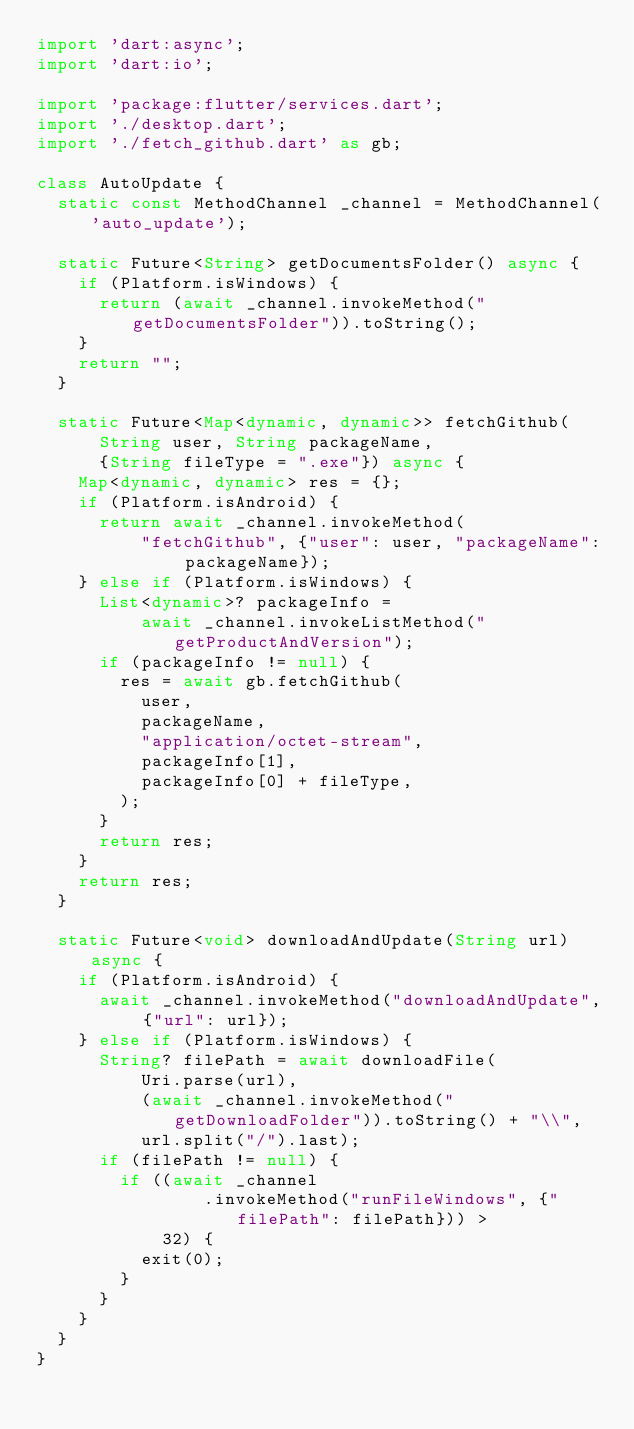Convert code to text. <code><loc_0><loc_0><loc_500><loc_500><_Dart_>import 'dart:async';
import 'dart:io';

import 'package:flutter/services.dart';
import './desktop.dart';
import './fetch_github.dart' as gb;

class AutoUpdate {
  static const MethodChannel _channel = MethodChannel('auto_update');

  static Future<String> getDocumentsFolder() async {
    if (Platform.isWindows) {
      return (await _channel.invokeMethod("getDocumentsFolder")).toString();
    }
    return "";
  }

  static Future<Map<dynamic, dynamic>> fetchGithub(
      String user, String packageName,
      {String fileType = ".exe"}) async {
    Map<dynamic, dynamic> res = {};
    if (Platform.isAndroid) {
      return await _channel.invokeMethod(
          "fetchGithub", {"user": user, "packageName": packageName});
    } else if (Platform.isWindows) {
      List<dynamic>? packageInfo =
          await _channel.invokeListMethod("getProductAndVersion");
      if (packageInfo != null) {
        res = await gb.fetchGithub(
          user,
          packageName,
          "application/octet-stream",
          packageInfo[1],
          packageInfo[0] + fileType,
        );
      }
      return res;
    }
    return res;
  }

  static Future<void> downloadAndUpdate(String url) async {
    if (Platform.isAndroid) {
      await _channel.invokeMethod("downloadAndUpdate", {"url": url});
    } else if (Platform.isWindows) {
      String? filePath = await downloadFile(
          Uri.parse(url),
          (await _channel.invokeMethod("getDownloadFolder")).toString() + "\\",
          url.split("/").last);
      if (filePath != null) {
        if ((await _channel
                .invokeMethod("runFileWindows", {"filePath": filePath})) >
            32) {
          exit(0);
        }
      }
    }
  }
}
</code> 